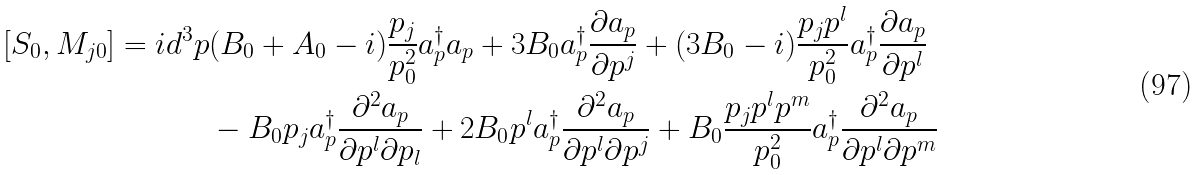Convert formula to latex. <formula><loc_0><loc_0><loc_500><loc_500>[ S _ { 0 } , M _ { j 0 } ] = i d ^ { 3 } p & ( B _ { 0 } + A _ { 0 } - i ) \frac { p _ { j } } { p _ { 0 } ^ { 2 } } a _ { p } ^ { \dagger } a _ { p } + 3 B _ { 0 } a _ { p } ^ { \dagger } \frac { \partial a _ { p } } { \partial p ^ { j } } + ( 3 B _ { 0 } - i ) \frac { p _ { j } p ^ { l } } { p _ { 0 } ^ { 2 } } a _ { p } ^ { \dagger } \frac { \partial a _ { p } } { \partial p ^ { l } } \\ & - B _ { 0 } p _ { j } a _ { p } ^ { \dagger } \frac { \partial ^ { 2 } a _ { p } } { \partial p ^ { l } \partial p _ { l } } + 2 B _ { 0 } p ^ { l } a _ { p } ^ { \dagger } \frac { \partial ^ { 2 } a _ { p } } { \partial p ^ { l } \partial p ^ { j } } + B _ { 0 } \frac { p _ { j } p ^ { l } p ^ { m } } { p _ { 0 } ^ { 2 } } a _ { p } ^ { \dagger } \frac { \partial ^ { 2 } a _ { p } } { \partial p ^ { l } \partial p ^ { m } }</formula> 